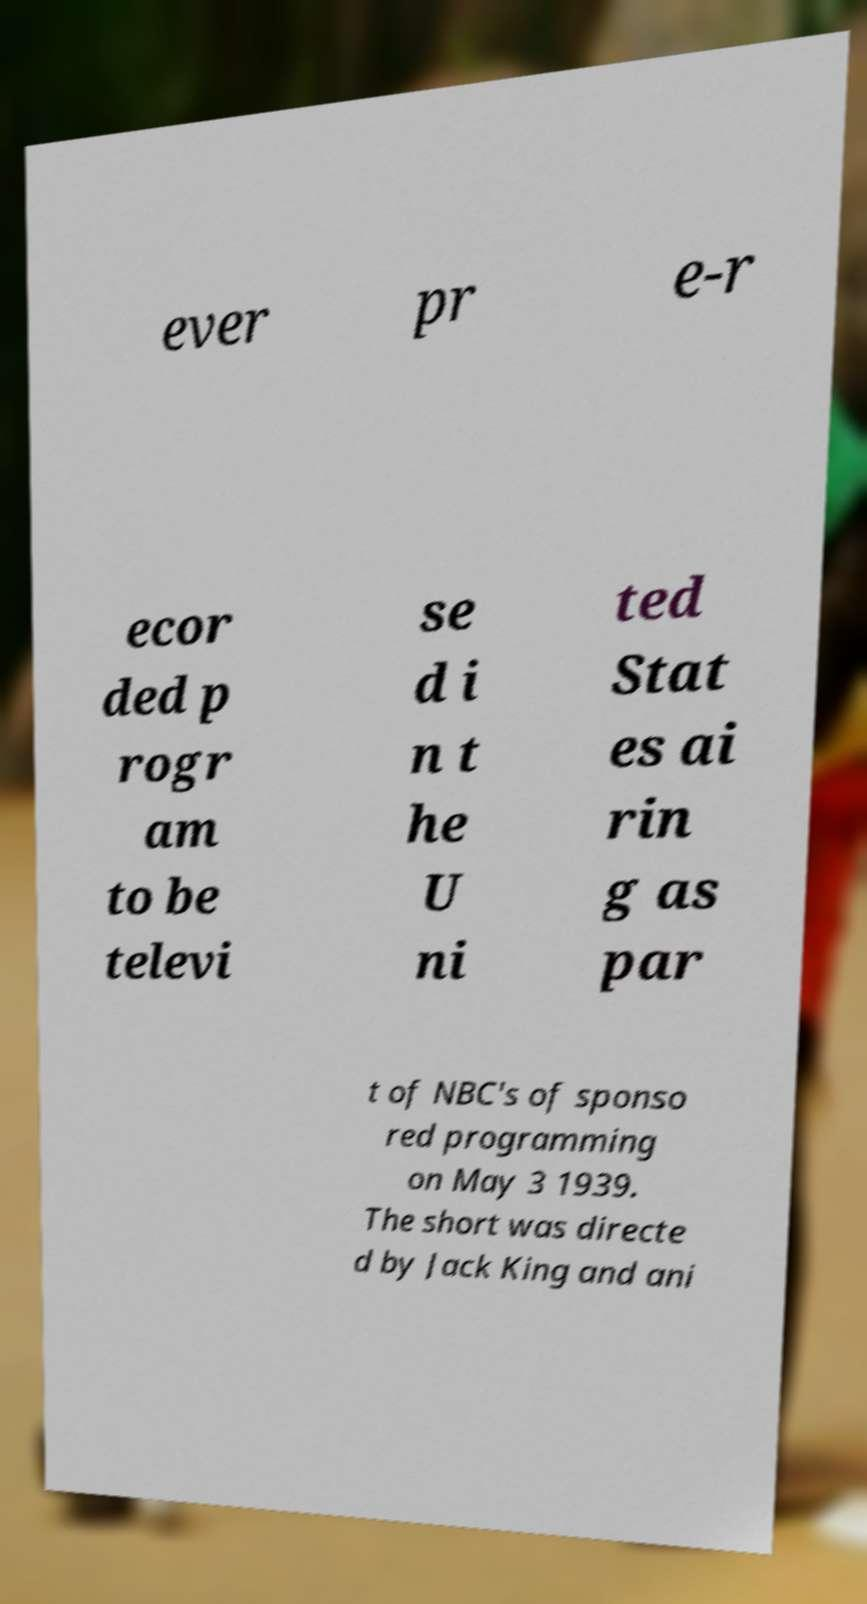Could you assist in decoding the text presented in this image and type it out clearly? ever pr e-r ecor ded p rogr am to be televi se d i n t he U ni ted Stat es ai rin g as par t of NBC's of sponso red programming on May 3 1939. The short was directe d by Jack King and ani 